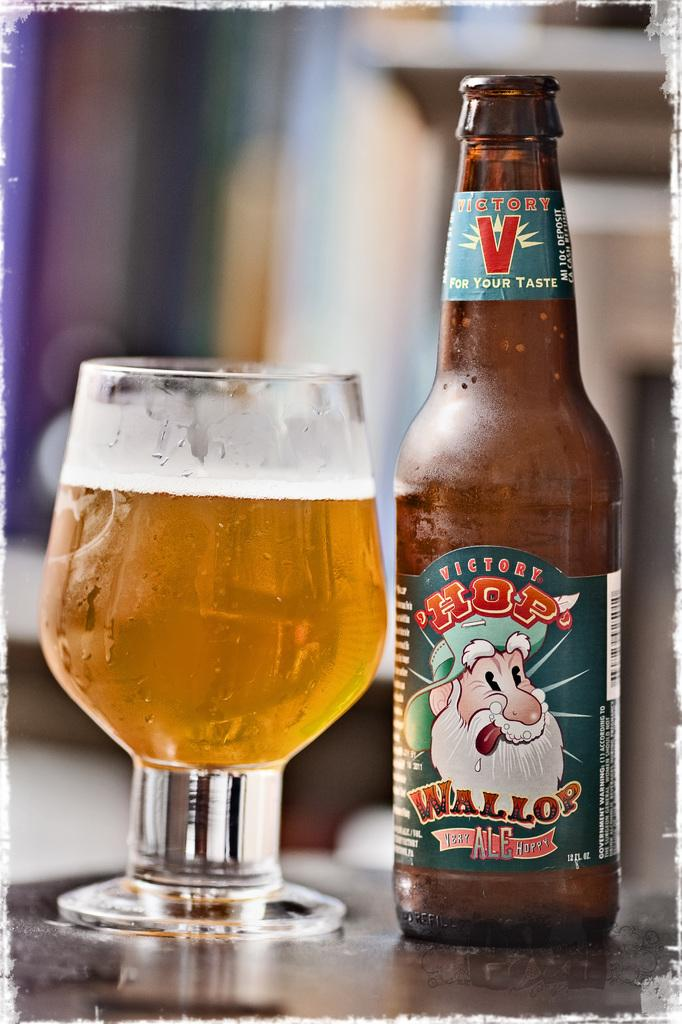Provide a one-sentence caption for the provided image. HOP Wollop ale is poured into a nice glass. 